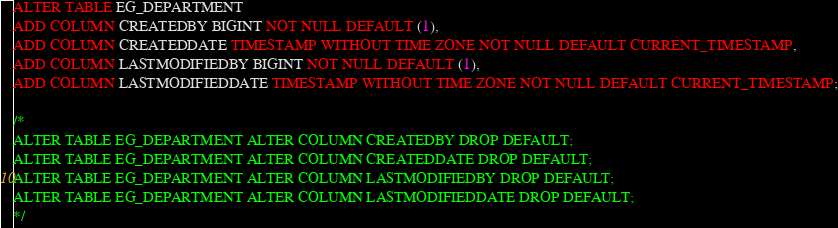<code> <loc_0><loc_0><loc_500><loc_500><_SQL_>ALTER TABLE EG_DEPARTMENT
ADD COLUMN CREATEDBY BIGINT NOT NULL DEFAULT (1), 
ADD COLUMN CREATEDDATE TIMESTAMP WITHOUT TIME ZONE NOT NULL DEFAULT CURRENT_TIMESTAMP,
ADD COLUMN LASTMODIFIEDBY BIGINT NOT NULL DEFAULT (1),
ADD COLUMN LASTMODIFIEDDATE TIMESTAMP WITHOUT TIME ZONE NOT NULL DEFAULT CURRENT_TIMESTAMP;

/*
ALTER TABLE EG_DEPARTMENT ALTER COLUMN CREATEDBY DROP DEFAULT;
ALTER TABLE EG_DEPARTMENT ALTER COLUMN CREATEDDATE DROP DEFAULT;
ALTER TABLE EG_DEPARTMENT ALTER COLUMN LASTMODIFIEDBY DROP DEFAULT;
ALTER TABLE EG_DEPARTMENT ALTER COLUMN LASTMODIFIEDDATE DROP DEFAULT;
*/
</code> 